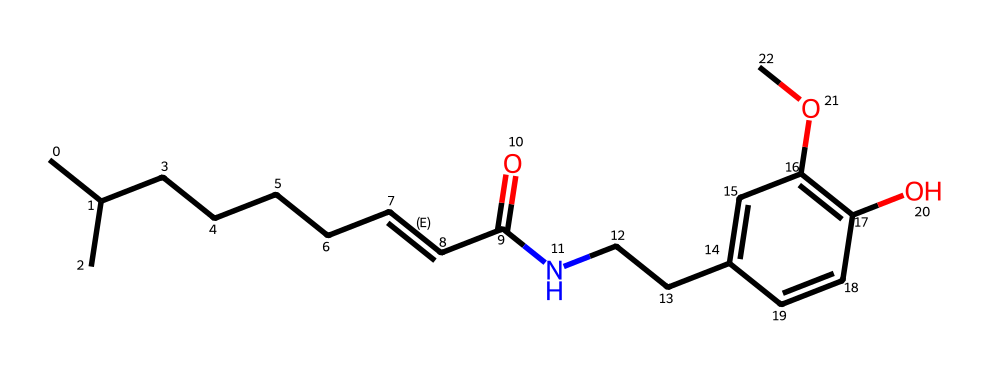What is the molecular formula of capsaicin? To find the molecular formula, we count the number of each type of atom in the SMILES representation. By analyzing the structure, we identify 18 carbon (C) atoms, 27 hydrogen (H) atoms, 2 nitrogen (N) atoms, and 3 oxygen (O) atoms. Therefore, the molecular formula is C18H27N3O3.
Answer: C18H27N3O3 How many rings are present in the chemical structure? In the given SMILES, the notation "1=CC(=C(C=C1)" indicates there is a cyclic structure. We note that the number "1" signifies a ring structure, which appears only once in the provided SMILES. Thus, there is one ring present.
Answer: 1 What functional group is indicated by "N" in the structure? The letter "N" in the SMILES denotes the presence of a nitrogen atom. In alkaloid structures, nitrogen atoms commonly signify the presence of an amine or amide functional group. In this case, it is connected as part of an amide group indicated by "C(=O)N."
Answer: amide How many double bonds are there in capsaicin? By analyzing the structure, we see a C=C double bond that is explicit in the "/C=C/" portion of the SMILES representation, indicating one double bond. Additionally, the carbonyl (C=O) in "C(=O)" is another double bond, making a total of two double bonds present in the molecule.
Answer: 2 What property is commonly associated with alkaloids like capsaicin? Alkaloids are often characterized by their physiological effects, which for capsaicin include pain relief and spiciness. This is primarily due to their interaction with receptors in the body, particularly nociceptors.
Answer: spiciness What is the relationship between the number of nitrogen atoms and the classification of a chemical as an alkaloid? Alkaloids typically contain at least one nitrogen atom, which is crucial for their classification. In capsaicin, the presence of two nitrogen atoms confirms its status as an alkaloid. Hence, we can deduce that having nitrogen atoms is a characteristic feature of alkaloids.
Answer: 2 nitrogen atoms What aspect of the structure gives capsaicin its spicy flavor? The spiciness of capsaicin is linked to its functional groups, mainly the presence of the hydrophobic tail along with the nitrogen group. This structure interacts with heat and pain receptors in the mouth, resulting in its spicy flavor. Therefore, the distinctive combination of structural features leads to this sensation.
Answer: functional groups 